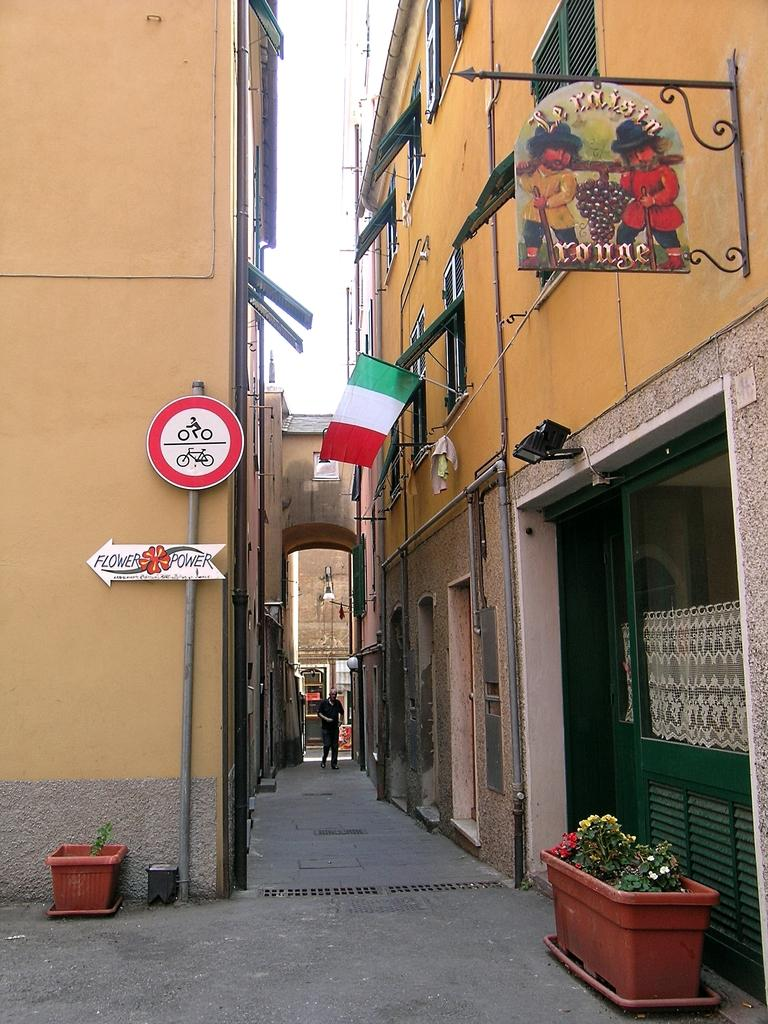What can be seen in the foreground of the image? In the foreground of the image, there is a path, flower pots, and boards. What structures are located on either side of the path? There are buildings on either side of the path. What feature is present in the middle of the path? There is an arch in the middle of the path. What is visible at the top of the image? The sky is visible at the top of the image. What type of fuel is being sold at the market in the image? There is no market or fuel present in the image; it features a path with buildings, an arch, and flower pots. What time of day is it in the image, based on the hour? The image does not provide information about the time of day or any specific hour. 